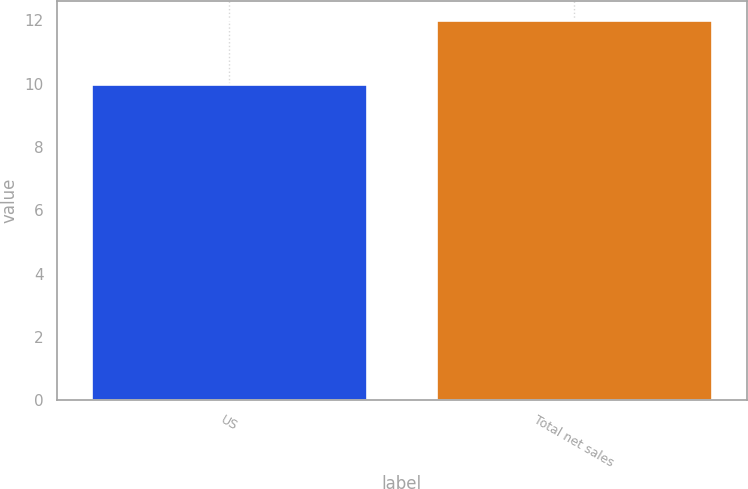Convert chart. <chart><loc_0><loc_0><loc_500><loc_500><bar_chart><fcel>US<fcel>Total net sales<nl><fcel>10<fcel>12<nl></chart> 